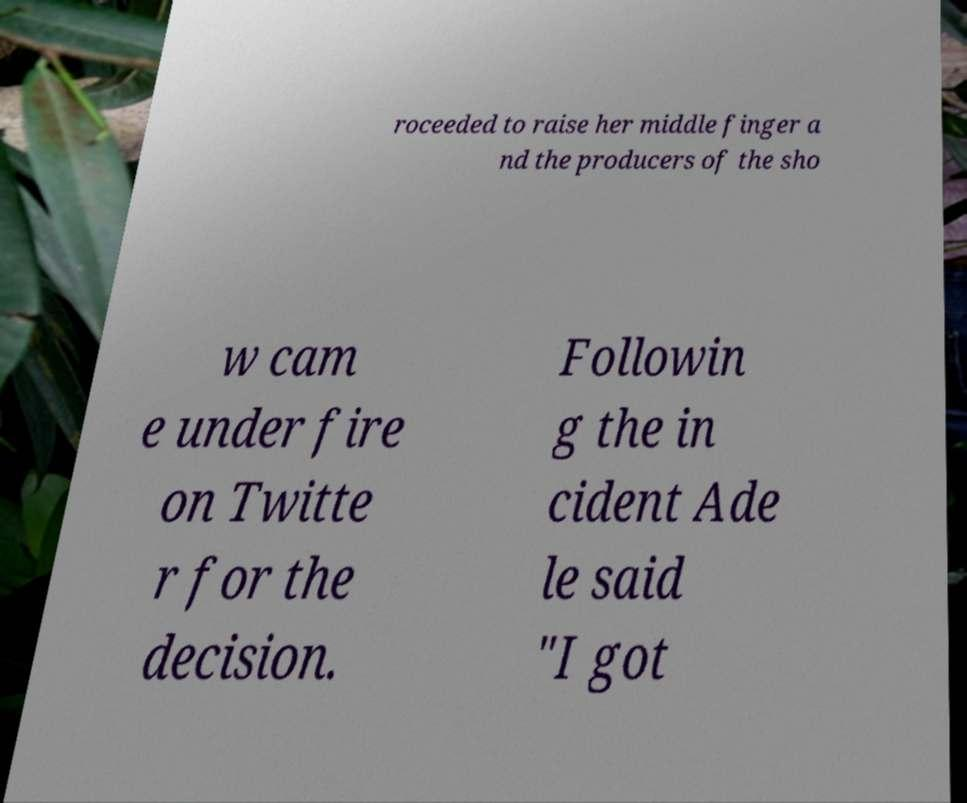Could you assist in decoding the text presented in this image and type it out clearly? roceeded to raise her middle finger a nd the producers of the sho w cam e under fire on Twitte r for the decision. Followin g the in cident Ade le said "I got 